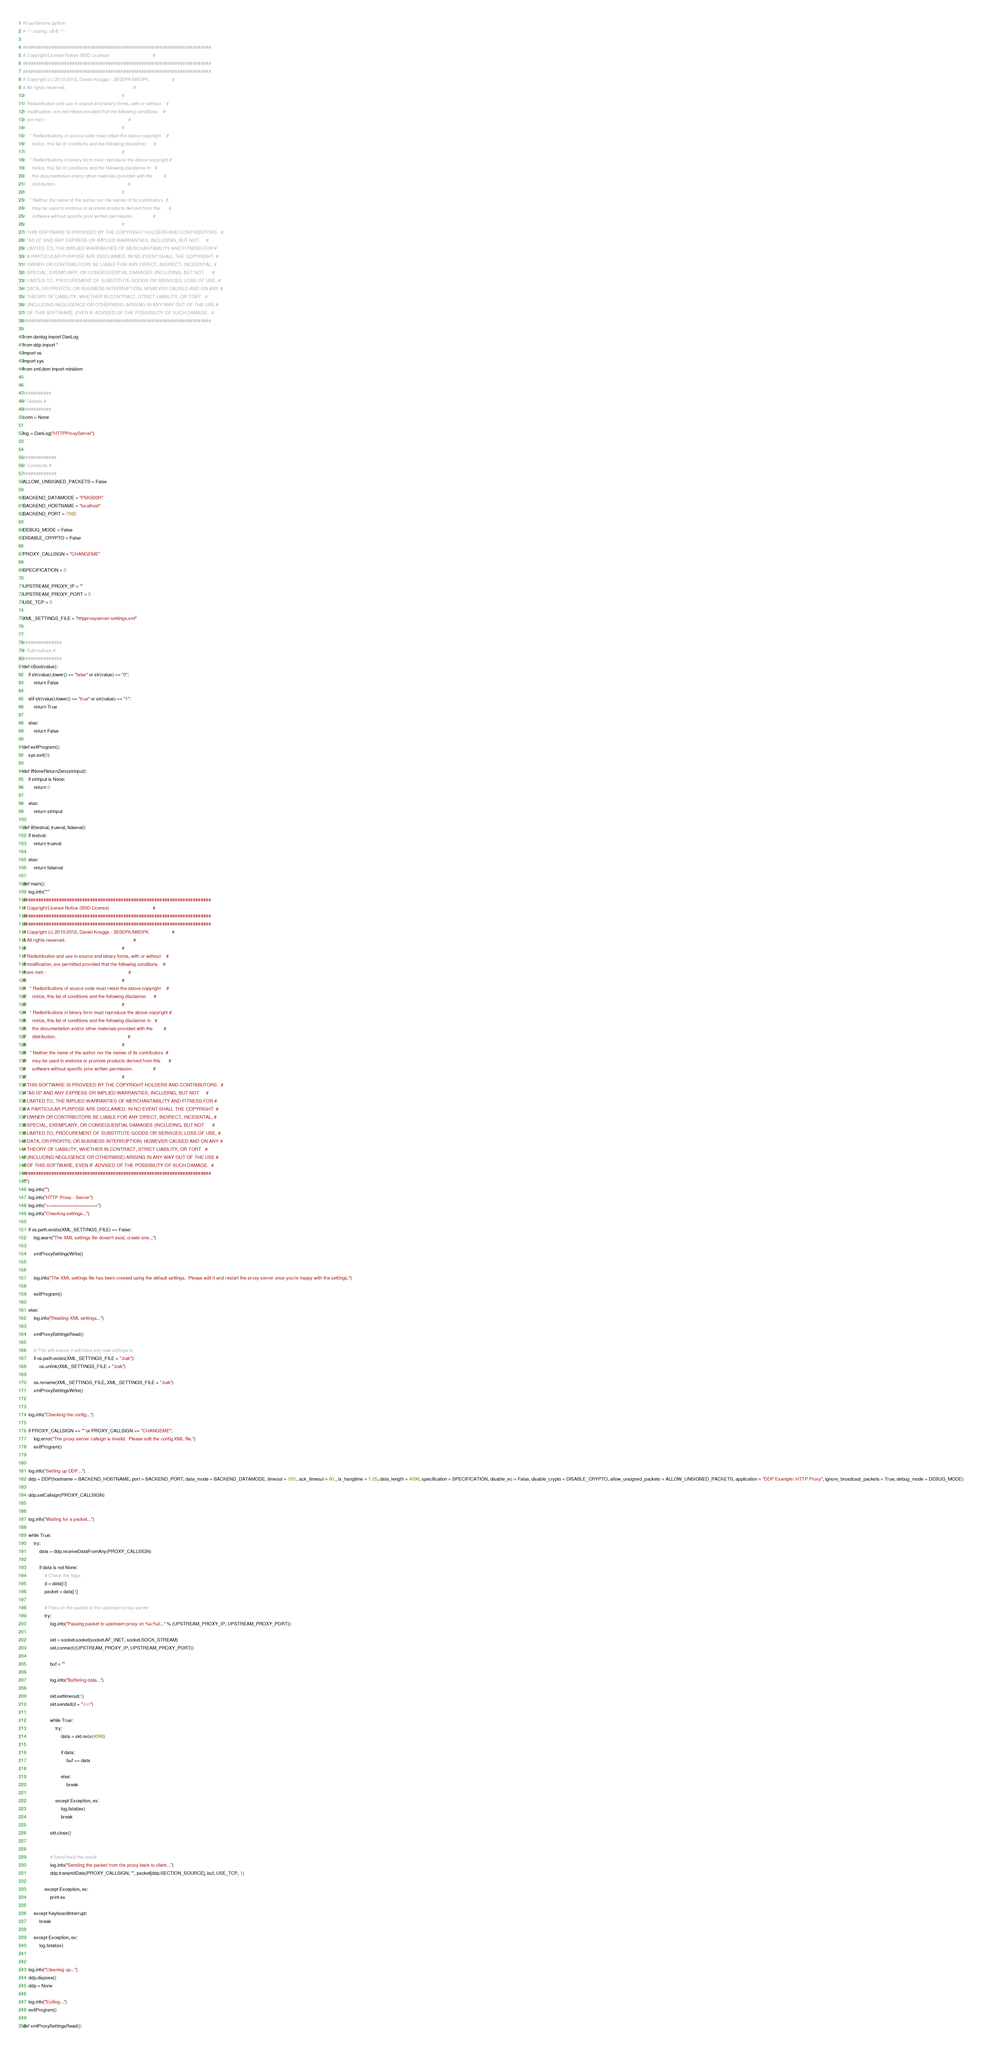<code> <loc_0><loc_0><loc_500><loc_500><_Python_>#!/usr/bin/env python
# -*- coding: utf-8 -*-

#########################################################################
# Copyright/License Notice (BSD License)                                #
#########################################################################
#########################################################################
# Copyright (c) 2010-2012, Daniel Knaggs - 2E0DPK/M6DPK                 #
# All rights reserved.                                                  #
#                                                                       #
# Redistribution and use in source and binary forms, with or without    #
# modification, are permitted provided that the following conditions    #
# are met: -                                                            #
#                                                                       #
#   * Redistributions of source code must retain the above copyright    #
#     notice, this list of conditions and the following disclaimer.     #
#                                                                       #
#   * Redistributions in binary form must reproduce the above copyright #
#     notice, this list of conditions and the following disclaimer in   #
#     the documentation and/or other materials provided with the        #
#     distribution.                                                     #
#                                                                       #
#   * Neither the name of the author nor the names of its contributors  #
#     may be used to endorse or promote products derived from this      #
#     software without specific prior written permission.               #
#                                                                       #
# THIS SOFTWARE IS PROVIDED BY THE COPYRIGHT HOLDERS AND CONTRIBUTORS   #
# "AS IS" AND ANY EXPRESS OR IMPLIED WARRANTIES, INCLUDING, BUT NOT     #
# LIMITED TO, THE IMPLIED WARRANTIES OF MERCHANTABILITY AND FITNESS FOR #
# A PARTICULAR PURPOSE ARE DISCLAIMED. IN NO EVENT SHALL THE COPYRIGHT  #
# OWNER OR CONTRIBUTORS BE LIABLE FOR ANY DIRECT, INDIRECT, INCIDENTAL, #
# SPECIAL, EXEMPLARY, OR CONSEQUENTIAL DAMAGES (INCLUDING, BUT NOT      #
# LIMITED TO, PROCUREMENT OF SUBSTITUTE GOODS OR SERVICES; LOSS OF USE, #
# DATA, OR PROFITS; OR BUSINESS INTERRUPTION) HOWEVER CAUSED AND ON ANY #
# THEORY OF LIABILITY, WHETHER IN CONTRACT, STRICT LIABILITY, OR TORT   #
# (INCLUDING NEGLIGENCE OR OTHERWISE) ARISING IN ANY WAY OUT OF THE USE #
# OF THIS SOFTWARE, EVEN IF ADVISED OF THE POSSIBILITY OF SUCH DAMAGE.  #
#########################################################################

from danlog import DanLog
from ddp import *
import os
import sys
from xml.dom import minidom


###########
# Globals #
###########
conn = None

log = DanLog("HTTPProxyServer")


#############
# Constants #
#############
ALLOW_UNSIGNED_PACKETS = False

BACKEND_DATAMODE = "PSK500R"
BACKEND_HOSTNAME = "localhost"
BACKEND_PORT = 7362

DEBUG_MODE = False
DISABLE_CRYPTO = False

PROXY_CALLSIGN = "CHANGEME"

SPECIFICATION = 0

UPSTREAM_PROXY_IP = ""
UPSTREAM_PROXY_PORT = 0
USE_TCP = 0

XML_SETTINGS_FILE = "httpproxyserver-settings.xml"


###############
# Subroutines #
###############
def cBool(value):
	if str(value).lower() == "false" or str(value) == "0":
		return False
		
	elif str(value).lower() == "true" or str(value) == "1":
		return True
		
	else:
		return False

def exitProgram():
	sys.exit(0)

def ifNoneReturnZero(strinput):
	if strinput is None:
		return 0
	
	else:
		return strinput

def iif(testval, trueval, falseval):
	if testval:
		return trueval
	
	else:
		return falseval

def main():
	log.info("""
#########################################################################
# Copyright/License Notice (BSD License)                                #
#########################################################################
#########################################################################
# Copyright (c) 2010-2012, Daniel Knaggs - 2E0DPK/M6DPK                 #
# All rights reserved.                                                  #
#                                                                       #
# Redistribution and use in source and binary forms, with or without    #
# modification, are permitted provided that the following conditions    #
# are met: -                                                            #
#                                                                       #
#   * Redistributions of source code must retain the above copyright    #
#     notice, this list of conditions and the following disclaimer.     #
#                                                                       #
#   * Redistributions in binary form must reproduce the above copyright #
#     notice, this list of conditions and the following disclaimer in   #
#     the documentation and/or other materials provided with the        #
#     distribution.                                                     #
#                                                                       #
#   * Neither the name of the author nor the names of its contributors  #
#     may be used to endorse or promote products derived from this      #
#     software without specific prior written permission.               #
#                                                                       #
# THIS SOFTWARE IS PROVIDED BY THE COPYRIGHT HOLDERS AND CONTRIBUTORS   #
# "AS IS" AND ANY EXPRESS OR IMPLIED WARRANTIES, INCLUDING, BUT NOT     #
# LIMITED TO, THE IMPLIED WARRANTIES OF MERCHANTABILITY AND FITNESS FOR #
# A PARTICULAR PURPOSE ARE DISCLAIMED. IN NO EVENT SHALL THE COPYRIGHT  #
# OWNER OR CONTRIBUTORS BE LIABLE FOR ANY DIRECT, INDIRECT, INCIDENTAL, #
# SPECIAL, EXEMPLARY, OR CONSEQUENTIAL DAMAGES (INCLUDING, BUT NOT      #
# LIMITED TO, PROCUREMENT OF SUBSTITUTE GOODS OR SERVICES; LOSS OF USE, #
# DATA, OR PROFITS; OR BUSINESS INTERRUPTION) HOWEVER CAUSED AND ON ANY #
# THEORY OF LIABILITY, WHETHER IN CONTRACT, STRICT LIABILITY, OR TORT   #
# (INCLUDING NEGLIGENCE OR OTHERWISE) ARISING IN ANY WAY OUT OF THE USE #
# OF THIS SOFTWARE, EVEN IF ADVISED OF THE POSSIBILITY OF SUCH DAMAGE.  #
#########################################################################
""")
	log.info("")
	log.info("HTTP Proxy - Server")
	log.info("===================")
	log.info("Checking settings...")
	
	if os.path.exists(XML_SETTINGS_FILE) == False:
		log.warn("The XML settings file doesn't exist, create one...")
		
		xmlProxySettingsWrite()
		
		
		log.info("The XML settings file has been created using the default settings.  Please edit it and restart the proxy server once you're happy with the settings.")
		
		exitProgram()
		
	else:
		log.info("Reading XML settings...")
		
		xmlProxySettingsRead()
		
		# This will ensure it will have any new settings in
		if os.path.exists(XML_SETTINGS_FILE + ".bak"):
			os.unlink(XML_SETTINGS_FILE + ".bak")
			
		os.rename(XML_SETTINGS_FILE, XML_SETTINGS_FILE + ".bak")
		xmlProxySettingsWrite()
	
	
	log.info("Checking the config...")
	
	if PROXY_CALLSIGN == "" or PROXY_CALLSIGN == "CHANGEME":
		log.error("The proxy server callsign is invalid.  Please edit the config XML file.")
		exitProgram()
		
	
	log.info("Setting up DDP...")
	ddp = DDP(hostname = BACKEND_HOSTNAME, port = BACKEND_PORT, data_mode = BACKEND_DATAMODE, timeout = 120., ack_timeout = 60., tx_hangtime = 1.25, data_length = 4096, specification = SPECIFICATION, disable_ec = False, disable_crypto = DISABLE_CRYPTO, allow_unsigned_packets = ALLOW_UNSIGNED_PACKETS, application = "DDP Example: HTTP Proxy", ignore_broadcast_packets = True, debug_mode = DEBUG_MODE)
	
	ddp.setCallsign(PROXY_CALLSIGN)
	
	
	log.info("Waiting for a packet...")
	
	while True:
		try:
			data = ddp.receiveDataFromAny(PROXY_CALLSIGN)
			
			if data is not None:
				# Check the flags
				d = data[0]
				packet = data[1]
				
				# Pass on the packet to the upstream proxy server
				try:
					log.info("Passing packet to upstream proxy on %s:%d..." % (UPSTREAM_PROXY_IP, UPSTREAM_PROXY_PORT))
					
					skt = socket.socket(socket.AF_INET, socket.SOCK_STREAM)
					skt.connect((UPSTREAM_PROXY_IP, UPSTREAM_PROXY_PORT))
					
					buf = ""
					
					log.info("Buffering data...")
					
					skt.settimeout(1)
					skt.sendall(d + "\n\n")
					
					while True:
						try:
							data = skt.recv(4096)
							
							if data:
								buf += data
								
							else:
								break
							
						except Exception, ex:
							log.fatal(ex)
							break
							
					skt.close()
					
					
					# Send back the result
					log.info("Sending the packet from the proxy back to client...")
					ddp.transmitData(PROXY_CALLSIGN, "", packet[ddp.SECTION_SOURCE], buf, USE_TCP, 1)
					
				except Exception, ex:
					print ex
					
		except KeyboardInterrupt:
			break
			
		except Exception, ex:
			log.fatal(ex)
	
	
	log.info("Cleaning up...")
	ddp.dispose()
	ddp = None
	
	log.info("Exiting...")
	exitProgram()
	
def xmlProxySettingsRead():</code> 